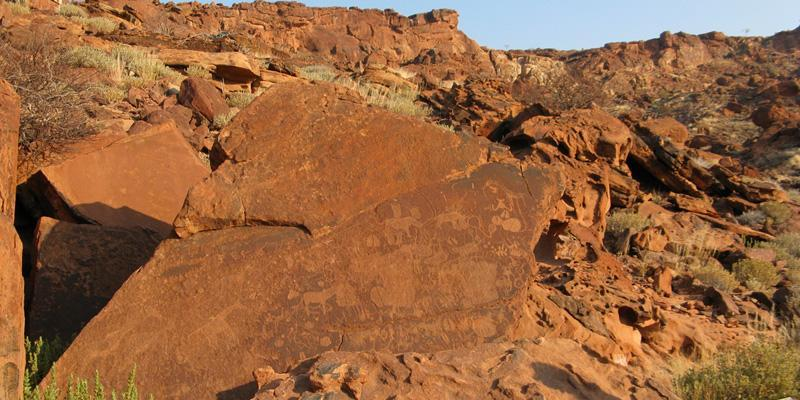What might the animal engravings on the rocks indicate about the people who created them? The animal engravings suggest that the creators had a profound connection with their environment, likely relying on these species for food, clothing, and tools. These depictions could serve as a form of spiritual expression or as a record of hunting rights and territorial boundaries. Such artwork provides valuable insights into their daily lives, beliefs, and social structures. 